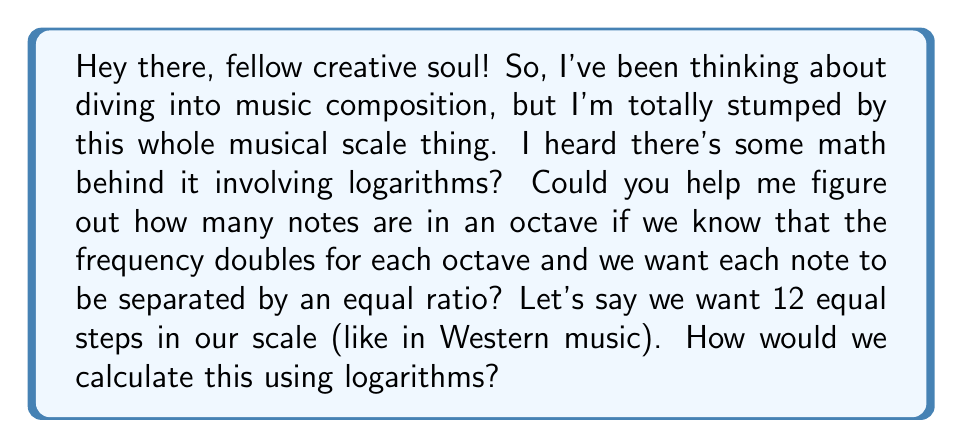Give your solution to this math problem. Alright, let's break this down step by step! It's actually pretty cool how math and music intersect here.

1) First, we need to understand what an octave means in terms of frequency. An octave is when the frequency doubles. So if we start at frequency $f$, the next octave would be at frequency $2f$.

2) Now, we want to divide this octave into equal steps. Let's call the number of steps $n$ (in Western music, $n = 12$).

3) We're looking for a ratio $r$ between consecutive notes such that when we apply this ratio $n$ times, we get from $f$ to $2f$. Mathematically, this means:

   $f \cdot r^n = 2f$

4) We can simplify this equation:

   $r^n = 2$

5) Now, we can use logarithms to solve for $r$. Let's take the logarithm (base 2) of both sides:

   $\log_2(r^n) = \log_2(2)$

6) Using the logarithm property $\log_a(x^n) = n\log_a(x)$, we get:

   $n \log_2(r) = 1$

7) Solving for $r$:

   $r = 2^{\frac{1}{n}}$

8) For Western music with 12 notes, we'd have:

   $r = 2^{\frac{1}{12}} \approx 1.0594631$

This means each note in the 12-tone scale is about 1.0594631 times the frequency of the previous note.

To find the number of notes given the ratio, we'd use:

$n = \frac{\log(2)}{\log(r)}$

This formula comes from rearranging the equation we derived earlier: $r = 2^{\frac{1}{n}}$
Answer: The number of notes in an octave for a given frequency ratio $r$ between consecutive notes is:

$n = \frac{\log(2)}{\log(r)}$

For the standard 12-tone equal temperament scale, $r \approx 1.0594631$, which gives us:

$n = \frac{\log(2)}{\log(1.0594631)} \approx 12$ 